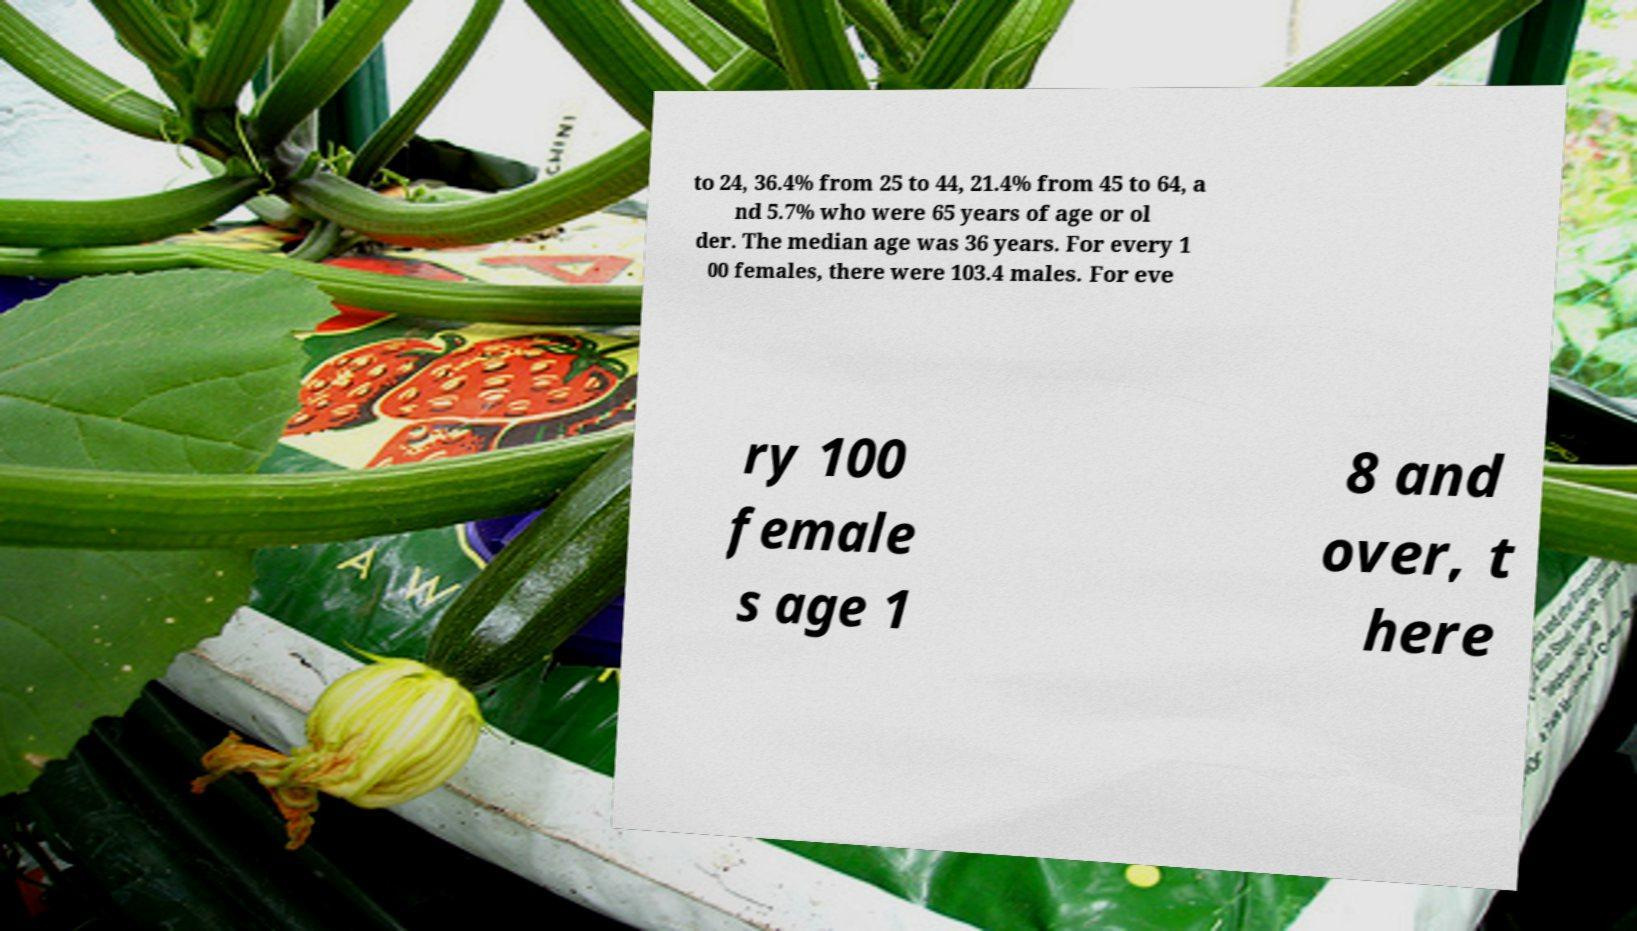There's text embedded in this image that I need extracted. Can you transcribe it verbatim? to 24, 36.4% from 25 to 44, 21.4% from 45 to 64, a nd 5.7% who were 65 years of age or ol der. The median age was 36 years. For every 1 00 females, there were 103.4 males. For eve ry 100 female s age 1 8 and over, t here 